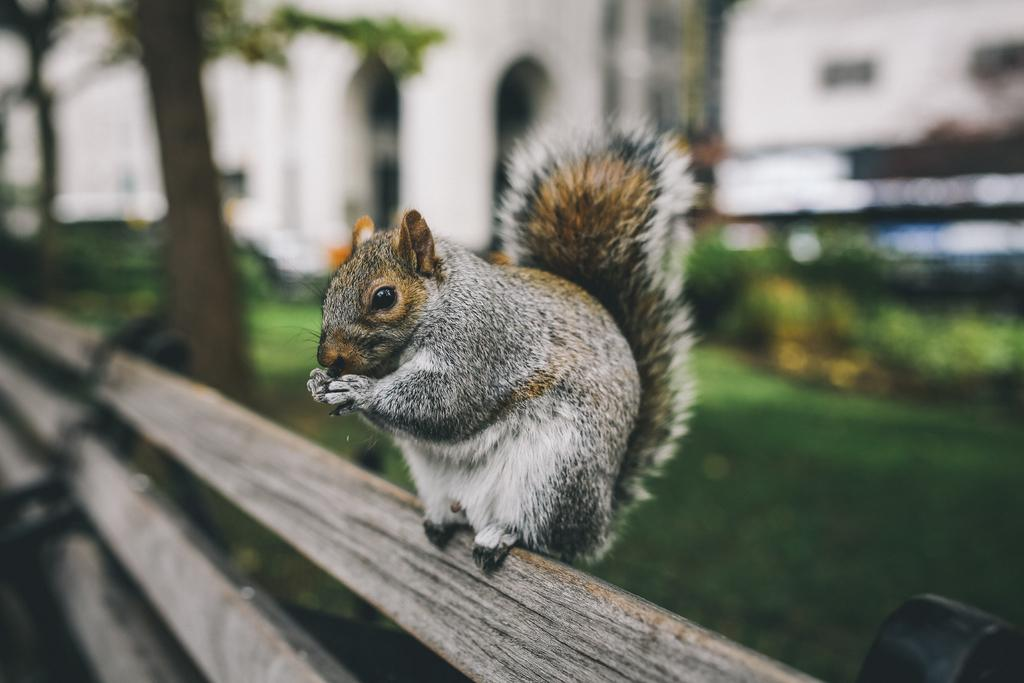What type of animal is in the image? There is a squirrel in the image. Where is the squirrel located? The squirrel is on a wooden object. What other natural elements can be seen in the image? There are plants and grass in the image. How would you describe the background of the image? The background of the image is blurred. What type of cub is playing with the cannon in the image? There is no cub or cannon present in the image; it features a squirrel on a wooden object with plants and grass in the background. 